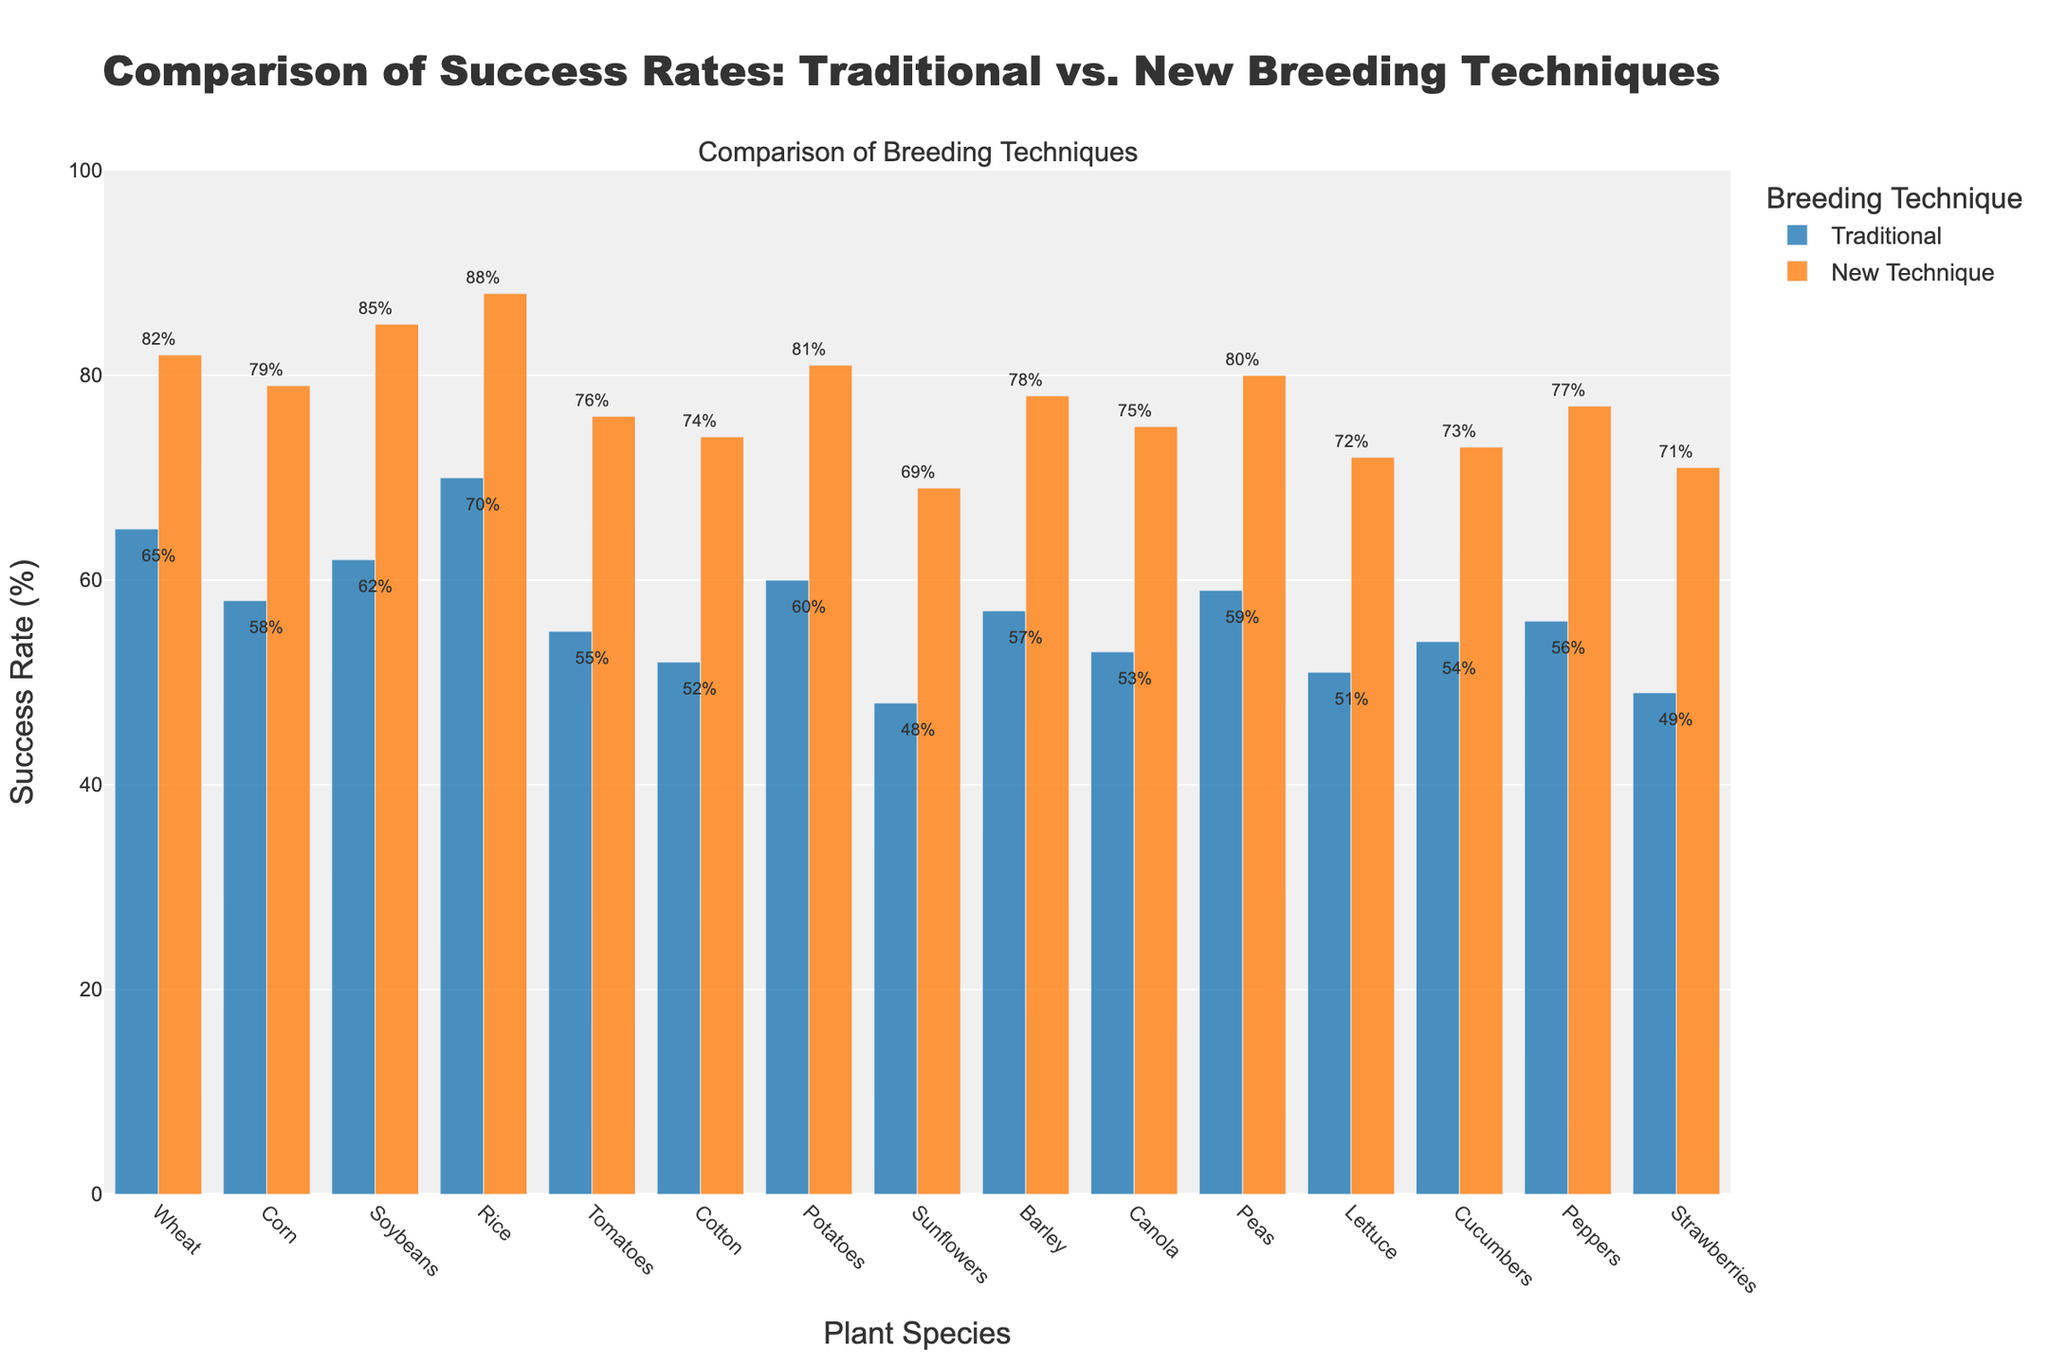what is the difference in success rates for Wheat between traditional and new techniques? For Wheat, the traditional breeding success rate is 65%, and the new technique success rate is 82%. The difference is calculated as 82% - 65% = 17%.
Answer: 17% Which species has the smallest improvement in success rate from traditional to new technique? By observing the differences between traditional and new techniques for each species, Sunflowers show the smallest improvement. The success rates are Traditional (48%) and New Technique (69%), with a difference of 69% - 48% = 21%.
Answer: Sunflowers What is the average success rate for traditional breeding across all species? Sum up the success rates for traditional breeding (65 + 58 + 62 + 70 + 55 + 52 + 60 + 48 + 57 + 53 + 59 + 51 + 54 + 56 + 49 = 799). There are 15 species, so the average is 799 / 15 ≈ 53.27%.
Answer: 53.27% Which species shows the highest success rate when using the new technique? By comparing the new technique success rates across all species, Rice has the highest success rate at 88%.
Answer: Rice How much higher is the success rate for Cucumbers using the new technique compared to traditional breeding? For Cucumbers, the success rates are Traditional (54%) and New Technique (73%). The difference is 73% - 54% = 19%.
Answer: 19% Which species has a traditional breeding success rate that is closer to the average success rate for new techniques? The average success rate for new techniques is (82 + 79 + 85 + 88 + 76 + 74 + 81 + 69 + 78 + 75 + 80 + 72 + 73 + 77 + 71) / 15 ≈ 77.33%. The traditional success rate closest to this average is Barley with 57%.
Answer: Barley What is the total improvement in success rate across all species using the new techniques? Calculate the improvements for each species and sum them: (82-65) + (79-58) + (85-62) + (88-70) + (76-55) + (74-52) + (81-60) + (69-48) + (78-57) + (75-53) + (80-59) + (72-51) + (73-54) + (77-56) + (71-49) = 42 + 17 + 23 + 18 + 21 + 22 + 21 + 24 + 21 + 22 + 21 + 21 + 19 + 21 + 22 = 335.
Answer: 335 Which species have a new technique success rate below 75%? Examine the new technique success rates and identify those below 75%. Sunflowers (69%), Lettuce (72%), Cucumbers (73%), and Strawberries (71%).
Answer: Sunflowers, Lettuce, Cucumbers, Strawberries 